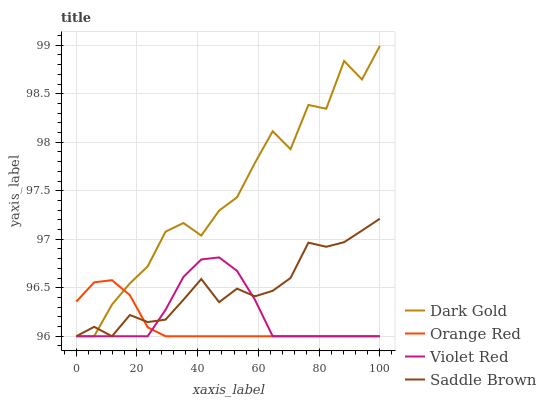Does Orange Red have the minimum area under the curve?
Answer yes or no. Yes. Does Dark Gold have the maximum area under the curve?
Answer yes or no. Yes. Does Violet Red have the minimum area under the curve?
Answer yes or no. No. Does Violet Red have the maximum area under the curve?
Answer yes or no. No. Is Orange Red the smoothest?
Answer yes or no. Yes. Is Dark Gold the roughest?
Answer yes or no. Yes. Is Violet Red the smoothest?
Answer yes or no. No. Is Violet Red the roughest?
Answer yes or no. No. Does Dark Gold have the highest value?
Answer yes or no. Yes. Does Violet Red have the highest value?
Answer yes or no. No. Does Dark Gold intersect Orange Red?
Answer yes or no. Yes. Is Dark Gold less than Orange Red?
Answer yes or no. No. Is Dark Gold greater than Orange Red?
Answer yes or no. No. 